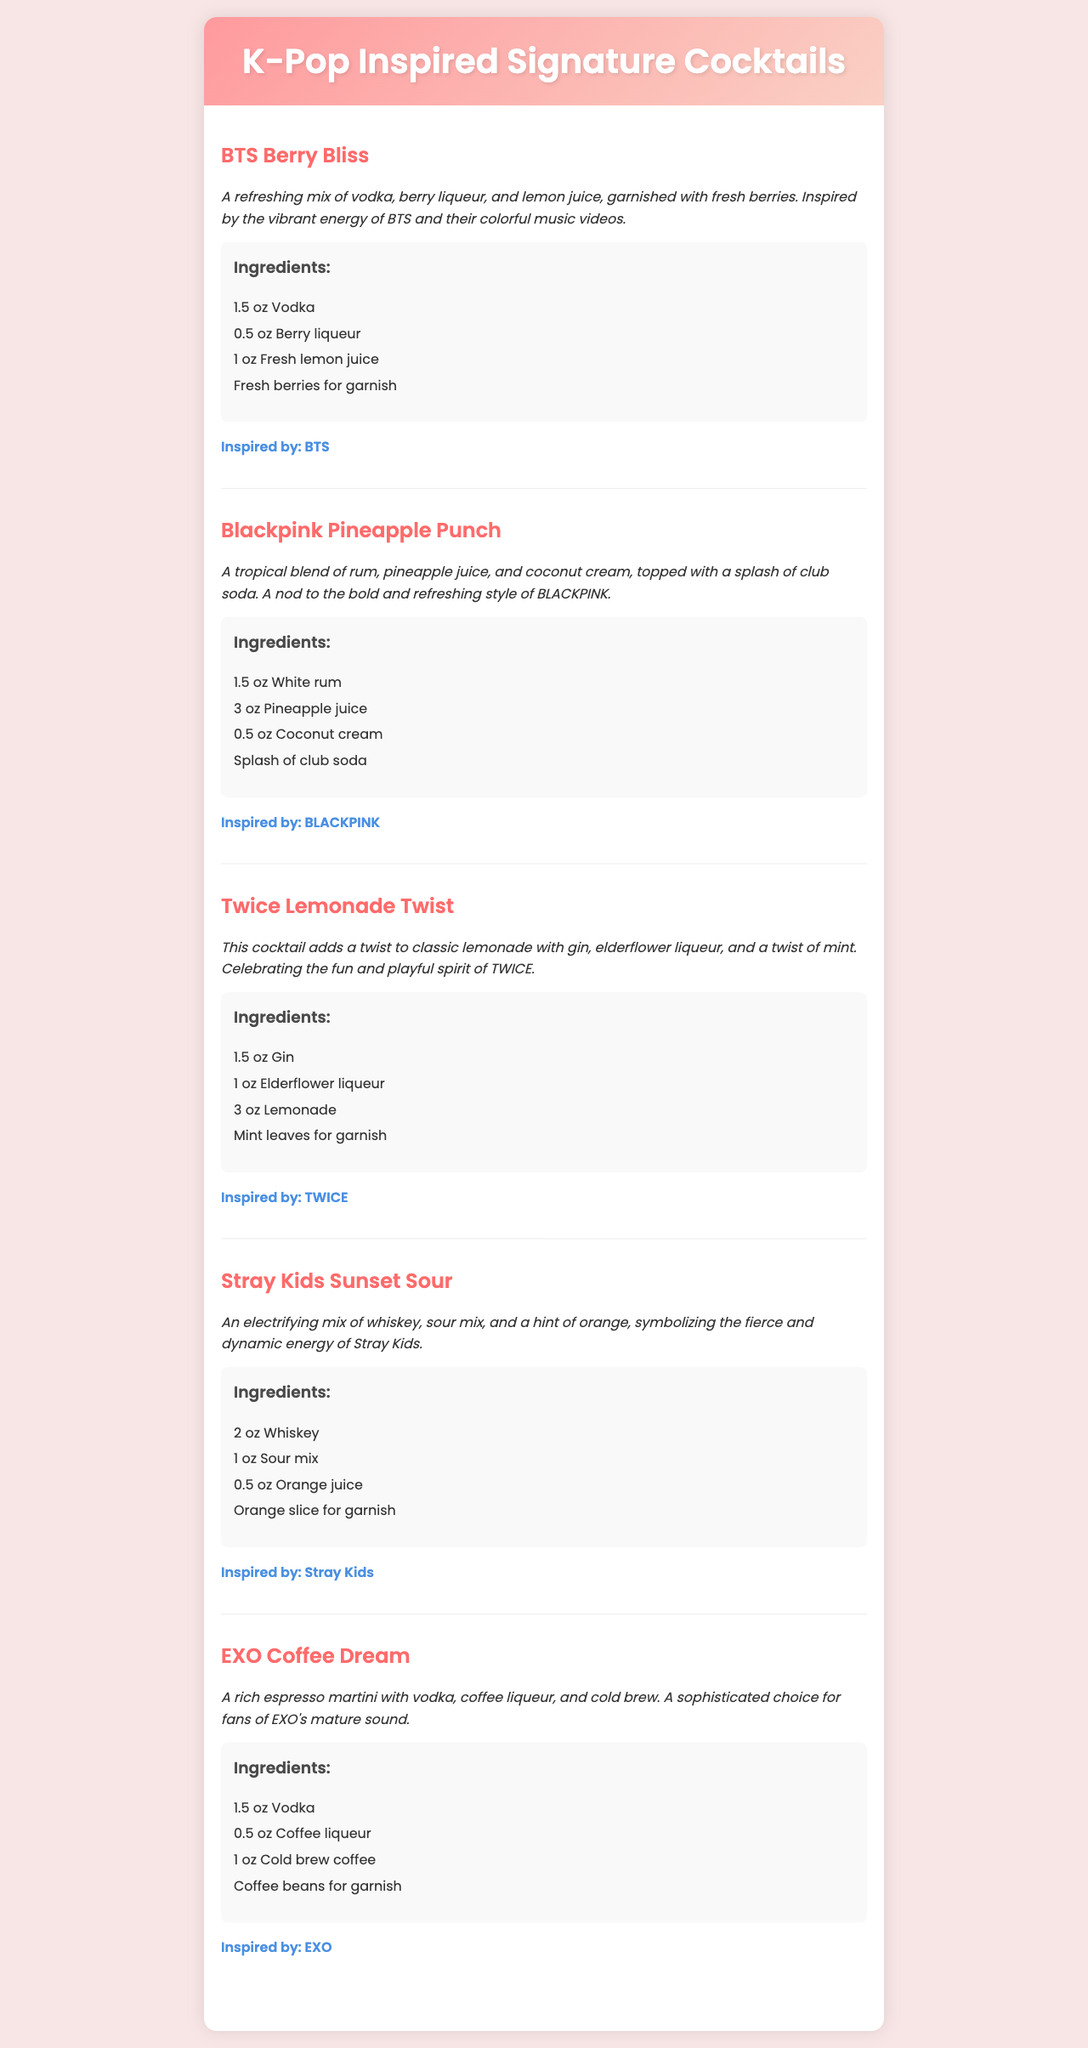What is the name of the cocktail inspired by BTS? The document lists "BTS Berry Bliss" as the cocktail associated with BTS.
Answer: BTS Berry Bliss Which cocktail features coconut cream? "Blackpink Pineapple Punch" includes coconut cream as one of its ingredients.
Answer: Blackpink Pineapple Punch How many ounces of whiskey are in the Stray Kids cocktail? The recipe for "Stray Kids Sunset Sour" specifies 2 ounces of whiskey.
Answer: 2 oz What type of liqueur is used in the Twice cocktail? The "Twice Lemonade Twist" includes elderflower liqueur among its ingredients.
Answer: Elderflower liqueur Which K-pop group is associated with the cocktail named "EXO Coffee Dream"? The name "EXO Coffee Dream" indicates it is inspired by the K-pop group EXO.
Answer: EXO What is the primary flavor profile of the "Stray Kids Sunset Sour"? The description mentions an electrifying mix which emphasizes a fierce and dynamic energy.
Answer: Fierce and dynamic How many cocktails are included in the menu? There are five distinct cocktails listed in the menu.
Answer: Five What is used for garnish in the BTS cocktail? The "BTS Berry Bliss" cocktail is garnished with fresh berries.
Answer: Fresh berries Which cocktail celebrates TWICE's fun spirit? The "Twice Lemonade Twist" is noted for celebrating TWICE's fun and playful spirit.
Answer: Twice Lemonade Twist 